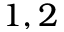Convert formula to latex. <formula><loc_0><loc_0><loc_500><loc_500>1 , 2</formula> 